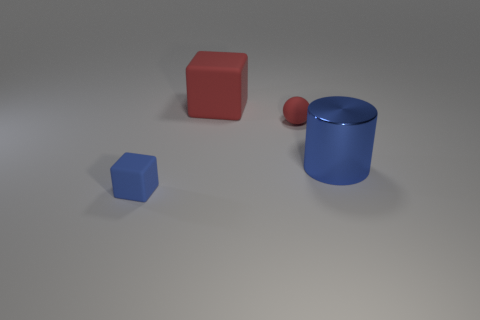Add 3 tiny spheres. How many objects exist? 7 Subtract all cylinders. How many objects are left? 3 Add 3 blue matte blocks. How many blue matte blocks are left? 4 Add 1 big green matte cylinders. How many big green matte cylinders exist? 1 Subtract 0 gray spheres. How many objects are left? 4 Subtract all large blue cylinders. Subtract all big green metal cubes. How many objects are left? 3 